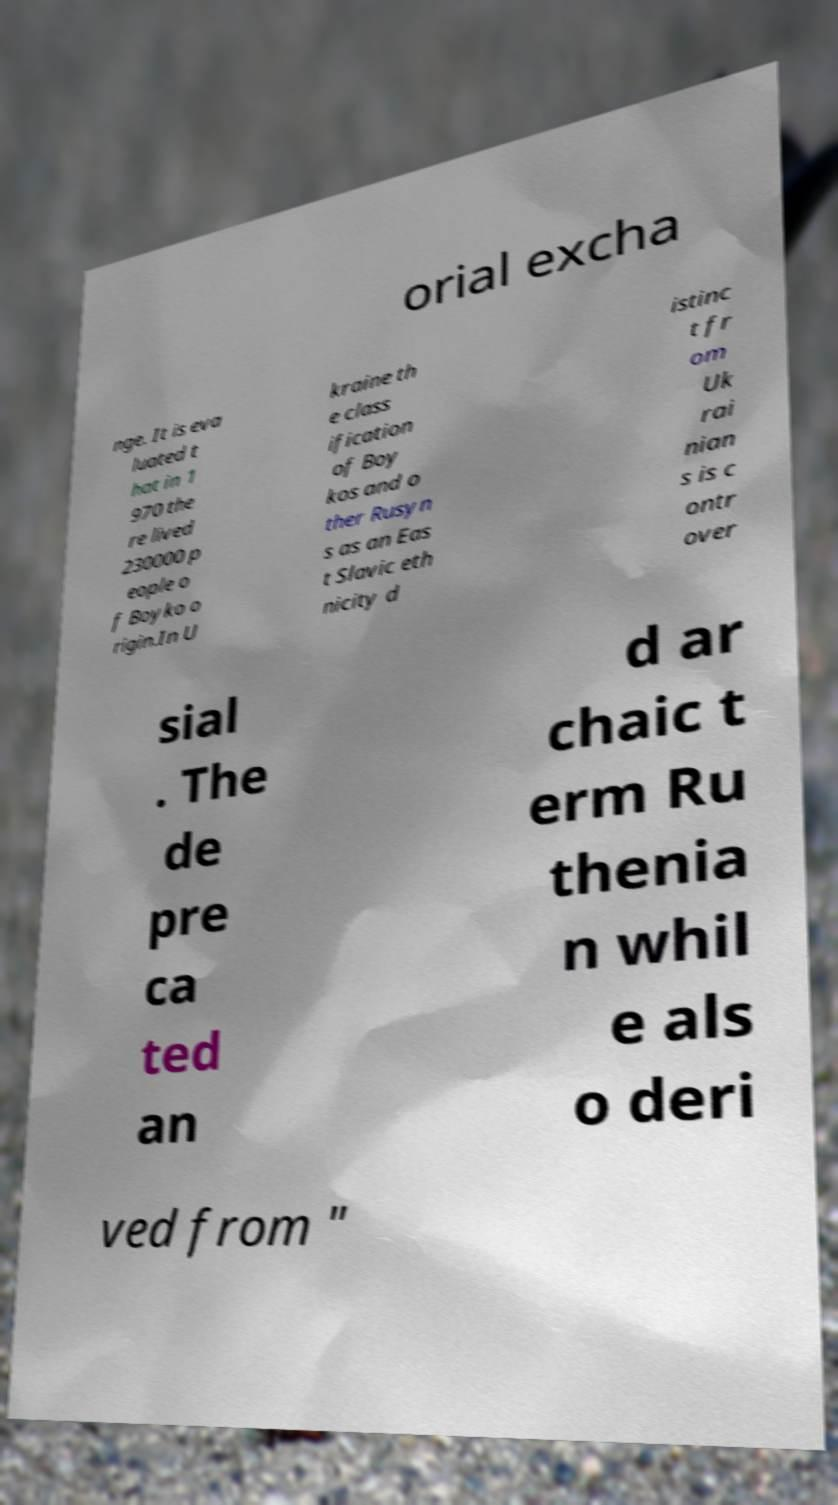What messages or text are displayed in this image? I need them in a readable, typed format. orial excha nge. It is eva luated t hat in 1 970 the re lived 230000 p eople o f Boyko o rigin.In U kraine th e class ification of Boy kos and o ther Rusyn s as an Eas t Slavic eth nicity d istinc t fr om Uk rai nian s is c ontr over sial . The de pre ca ted an d ar chaic t erm Ru thenia n whil e als o deri ved from " 